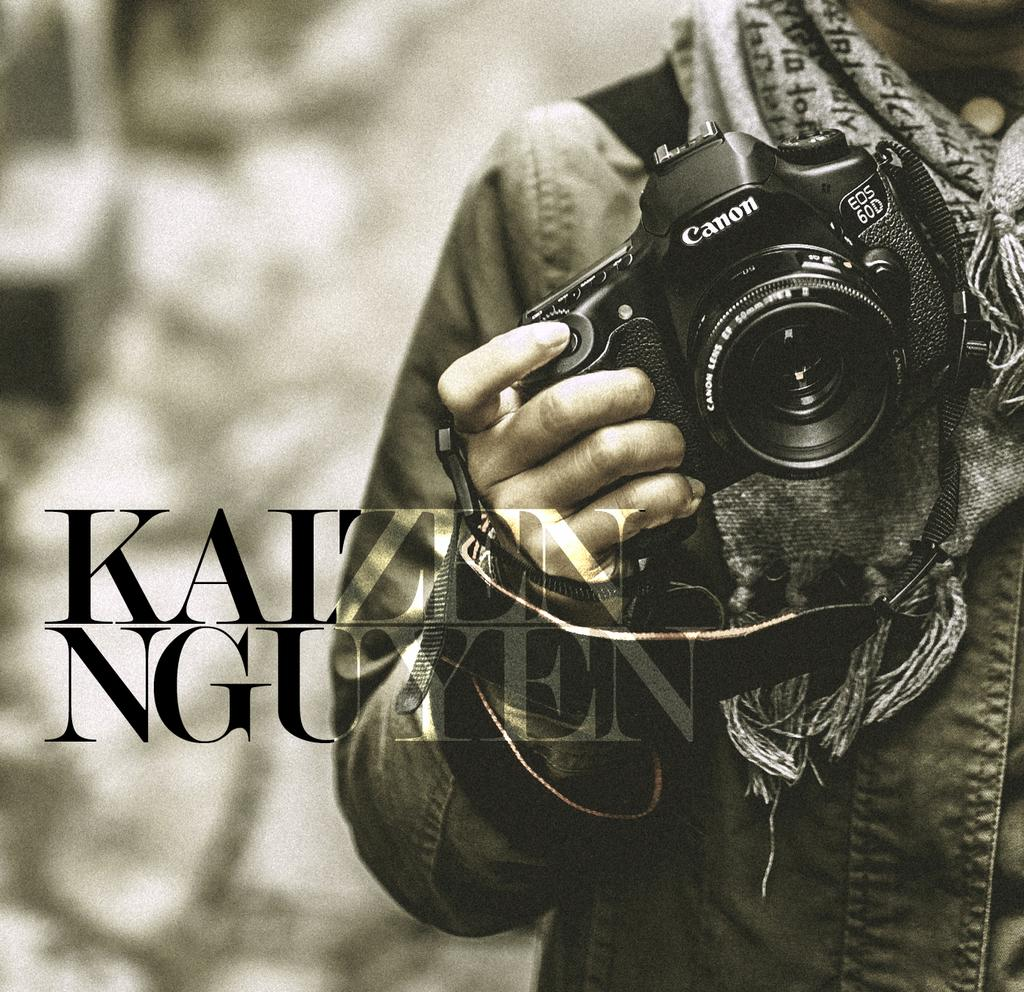Who or what is present on the right side of the image? There is a person on the right side of the image. What is the person holding in the image? The person is holding a camera. What can be seen in the center of the image? There is a watermark in the center of the image. What type of book is being read by the person in the image? There is no book present in the image; the person is holding a camera. 